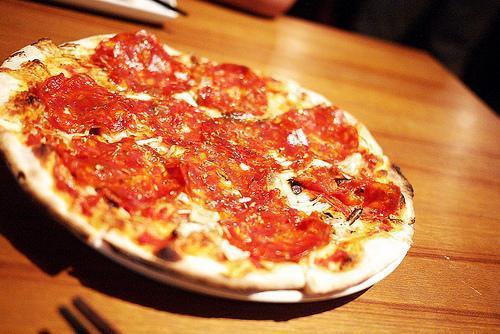How many pizzas are there?
Give a very brief answer. 1. 